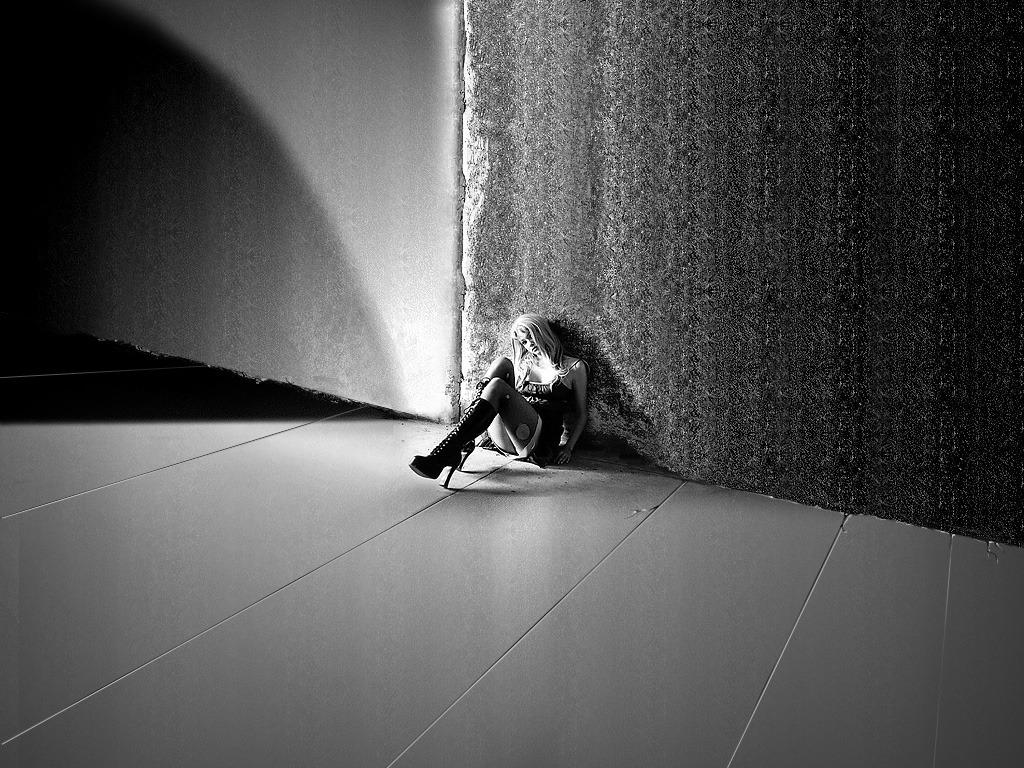What is the color scheme of the image? The image is black and white. Who is present in the image? There is a woman in the image. What is the woman doing in the image? The woman is sitting on the floor. What can be seen in the background of the image? There is a wall visible in the background of the image. How many robins are perched on the wall in the image? There are no robins present in the image; it only features a woman sitting on the floor. 